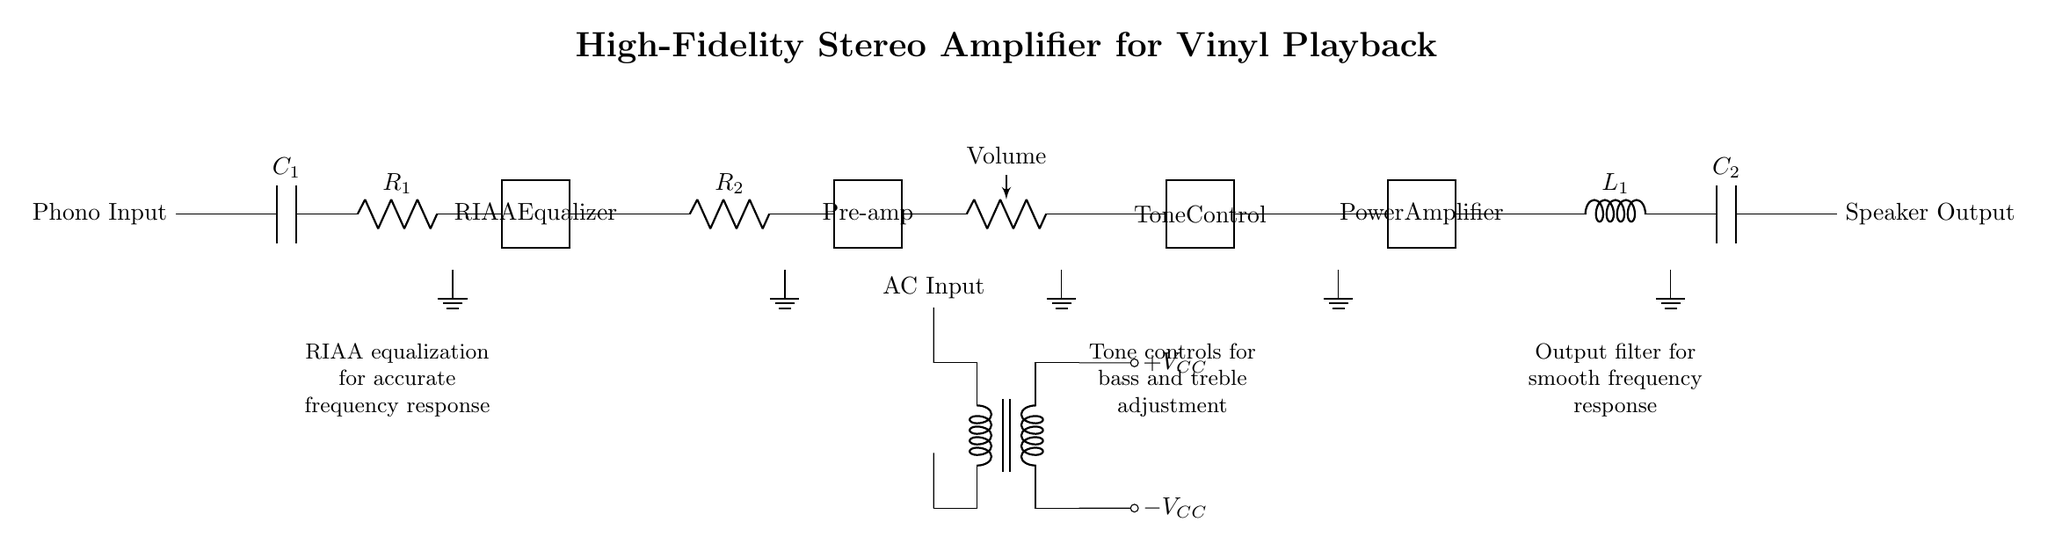What is the purpose of the capacitor labeled C1? The capacitor C1 is positioned at the phono input stage and serves to filter and couple the audio signal coming from the vinyl source, blocking any DC component while allowing AC signals (audio) to pass through.
Answer: To filter audio What component is used for RIAA equalization? In the circuit, the two-port labeled as RIAA Equalizer is responsible for applying the RIAA curve equalization, which compensates for the frequency response of vinyl records to ensure accurate playback.
Answer: RIAA Equalizer What is the total number of resistors in this circuit? The circuit contains three resistors, specifically R1, R2, and the volume control resistor (indicated as "Volume"). Each resistor plays a role in controlling gain and adjusting signal levels.
Answer: Three What does the output filter consist of? The output filter consists of an inductor labeled L1 and a capacitor labeled C2, which together smooth out the frequency response of the signal before sending it to the speaker output.
Answer: Inductor and capacitor Which stage is responsible for tone control? The stage labeled "Tone Control" is explicitly designed for adjusting the tone of the audio signal, allowing users to modify bass and treble frequencies as desired.
Answer: Tone Control How many power supply voltages are indicated in the circuit? The circuit indicates two power supply voltages, +VCC and -VCC, which provide the dual supply necessary for the operation of the amplifier, enabling it to handle the full waveform of the audio signal.
Answer: Two What is the main purpose of the pre-amplifier stage? The pre-amplifier stage is crucial for amplifying the weak audio signal from the phono input to a level suitable for further processing by the subsequent stages of the amplifier prior to output.
Answer: To amplify audio 